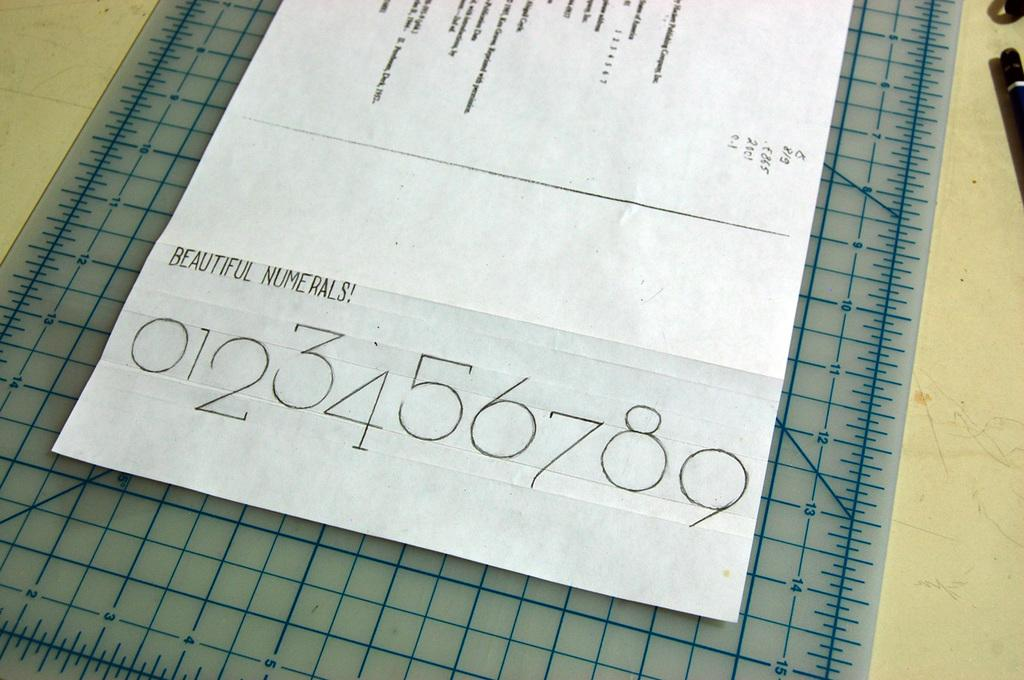<image>
Describe the image concisely. Piece of Paper on a measuring board that says Beautiful Numberals 0-9. 